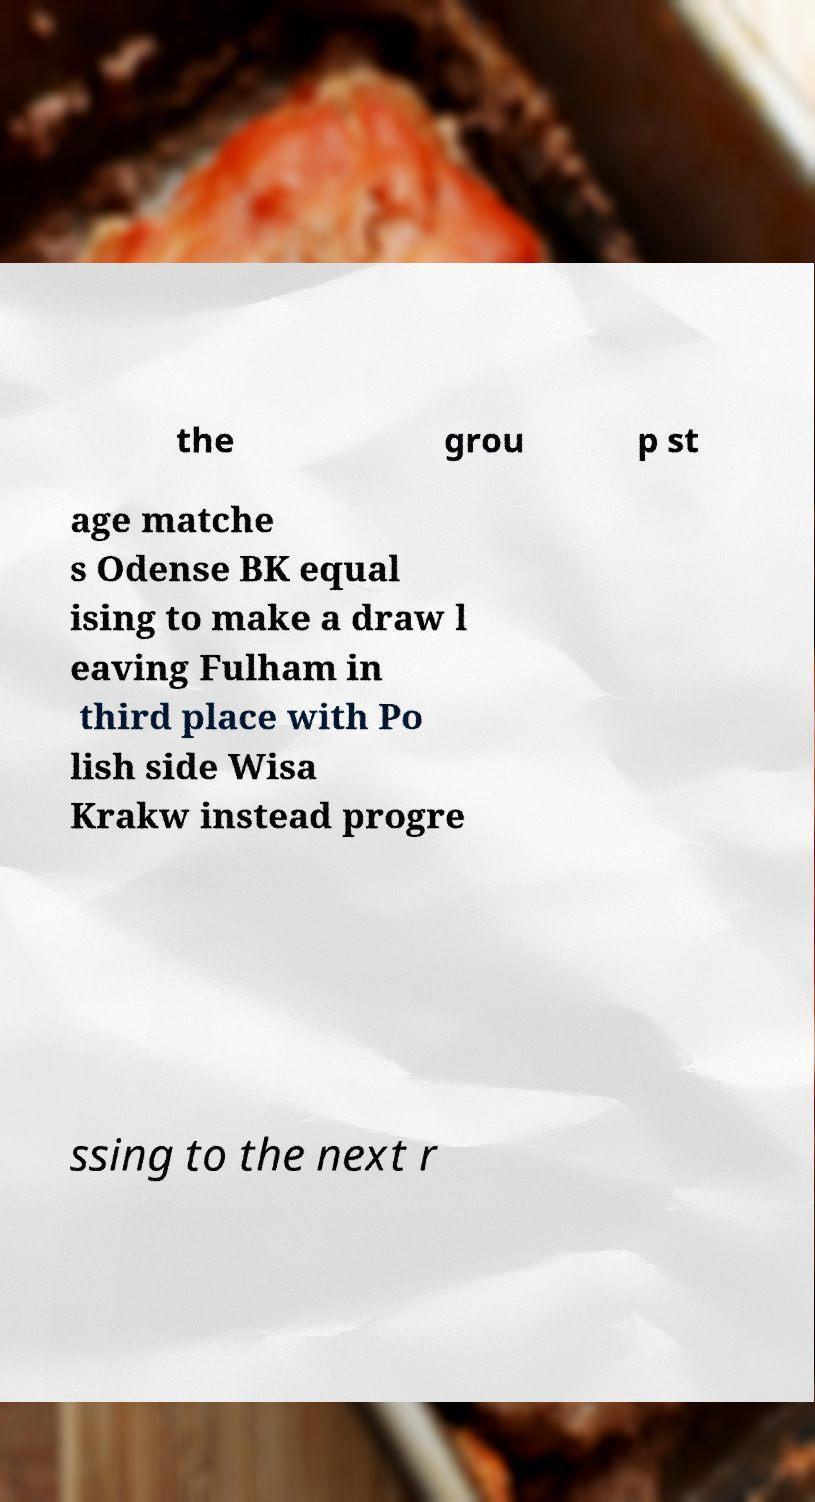Could you extract and type out the text from this image? the grou p st age matche s Odense BK equal ising to make a draw l eaving Fulham in third place with Po lish side Wisa Krakw instead progre ssing to the next r 